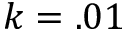Convert formula to latex. <formula><loc_0><loc_0><loc_500><loc_500>k = . 0 1</formula> 